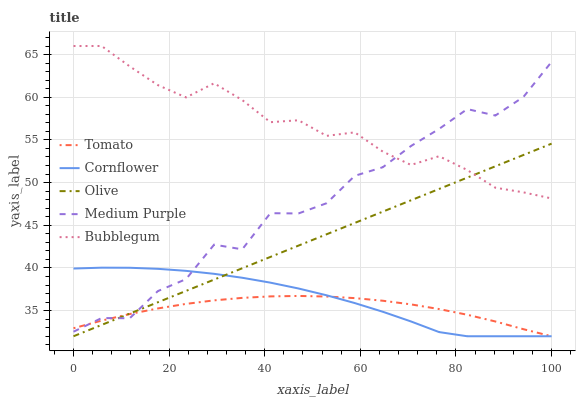Does Cornflower have the minimum area under the curve?
Answer yes or no. No. Does Cornflower have the maximum area under the curve?
Answer yes or no. No. Is Cornflower the smoothest?
Answer yes or no. No. Is Cornflower the roughest?
Answer yes or no. No. Does Medium Purple have the lowest value?
Answer yes or no. No. Does Cornflower have the highest value?
Answer yes or no. No. Is Cornflower less than Bubblegum?
Answer yes or no. Yes. Is Bubblegum greater than Tomato?
Answer yes or no. Yes. Does Cornflower intersect Bubblegum?
Answer yes or no. No. 